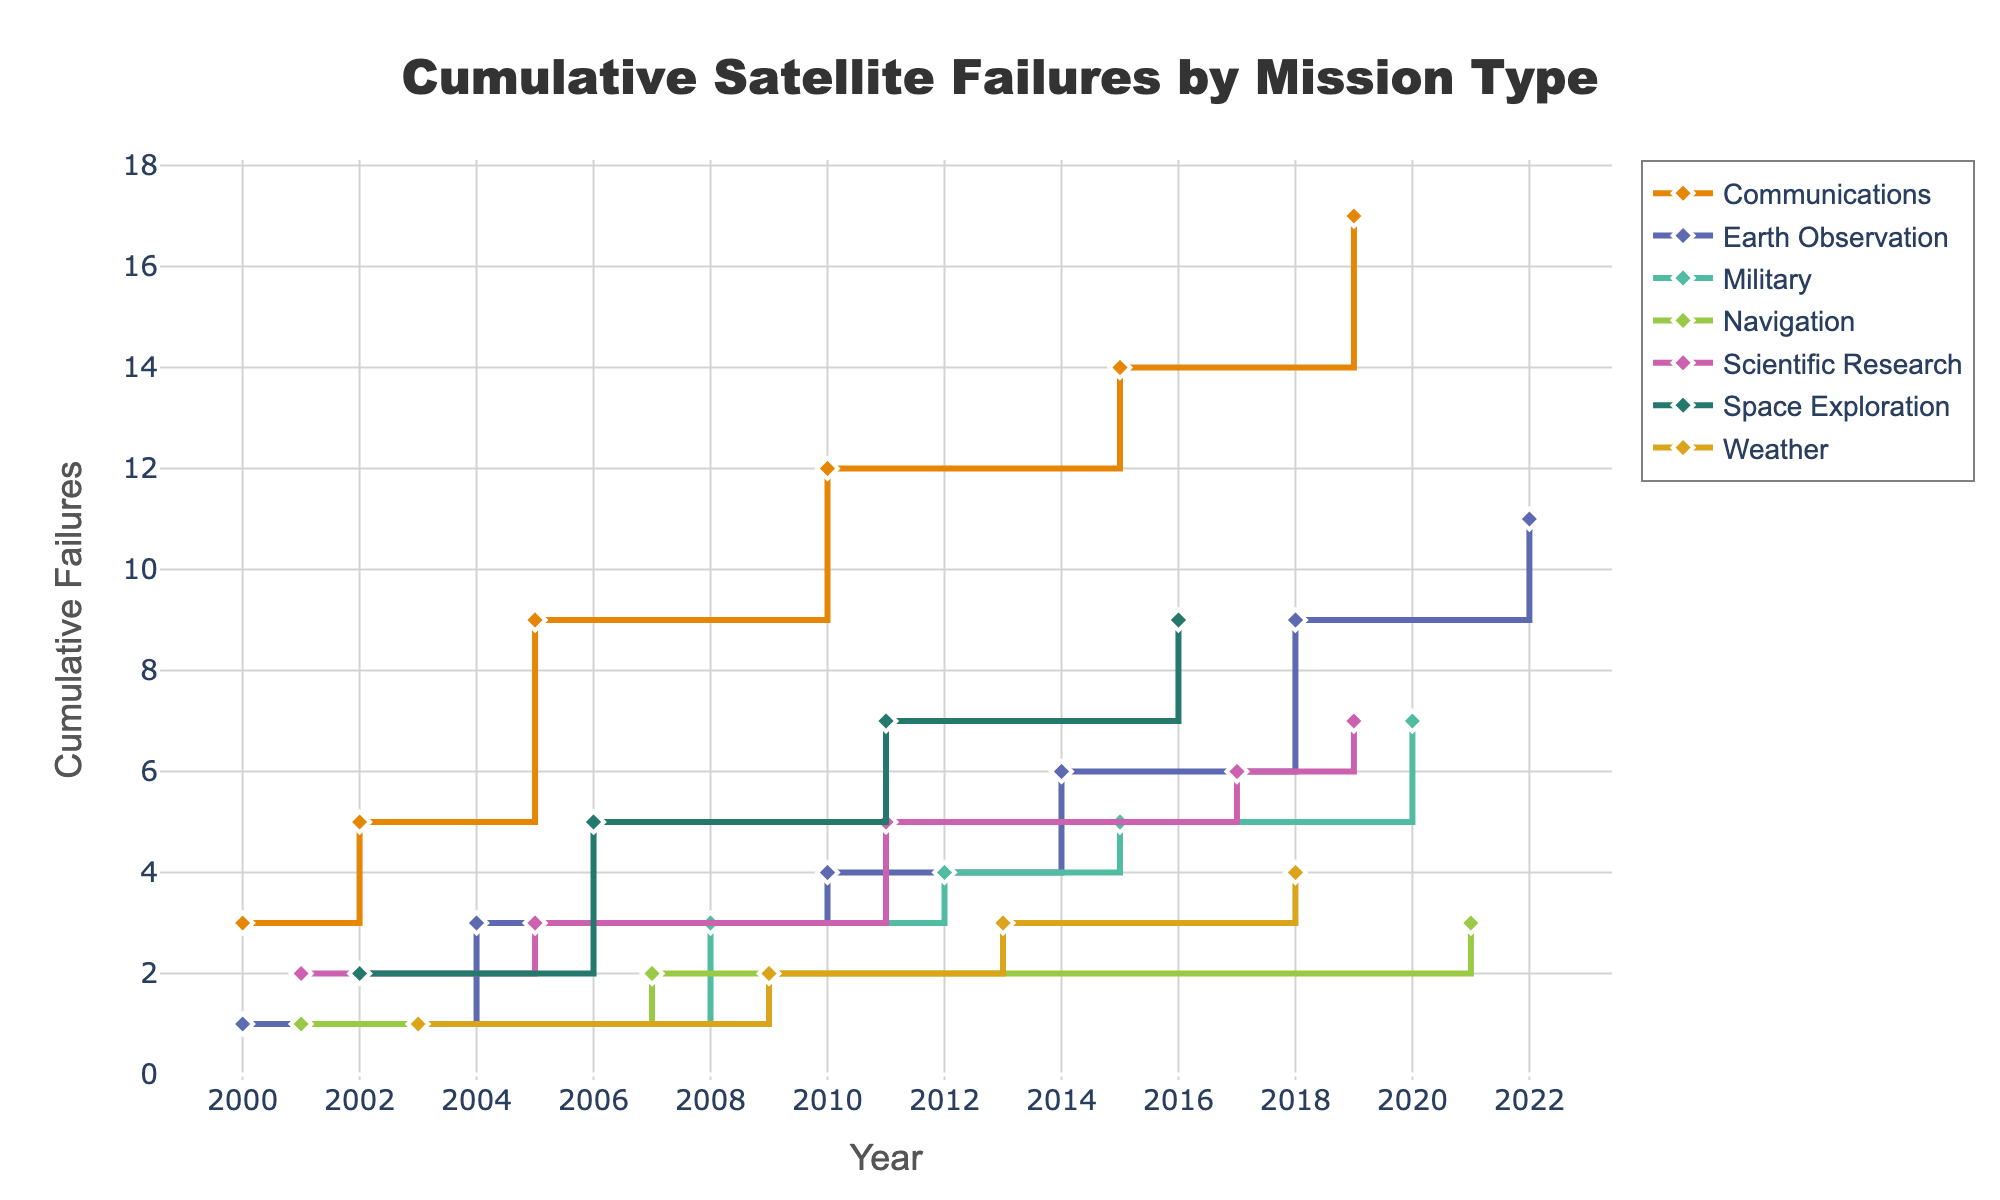What's the title of the plot? The title of the plot is displayed at the top center of the figure and reads "Cumulative Satellite Failures by Mission Type."
Answer: Cumulative Satellite Failures by Mission Type What is represented on the x-axis? The x-axis represents "Year," which indicates the years ranging from 2000 to 2022.
Answer: Year How many cumulative failures are present for the "Communications" mission type by the year 2019? Identify the trend line for the "Communications" mission type and find the cumulative failures at the point marked for the year 2019. The cumulative failures for "Communications" in 2019 are 15.
Answer: 15 Which mission type has the highest cumulative failures by 2022? Observe the final cumulative values for each line representing different mission types in the year 2022. The "Communications" mission type has the highest cumulative failures by 2022.
Answer: Communications How many mission types are there in total? Count the distinct lines (each with different colors and possibly different markers) representing various mission types in the plot. There are 8 distinct mission types.
Answer: 8 Comparing "Military" and "Weather," which mission type had more cumulative failures by 2015? Identify the trend lines for "Military" and "Weather" and compare their respective cumulative failures at the year 2015. "Military" had more cumulative failures by 2015 (with 1 for "Weather" and 4 for "Military").
Answer: Military What is the cumulative difference in failures between "Scientific Research" and "Navigation" by 2021? Track the cumulative trend lines for "Scientific Research" and "Navigation" and calculate the difference in their cumulative failures by 2021 (10 for "Scientific Research" - 3 for "Navigation" = 7).
Answer: 7 How did the "Space Exploration" mission type's cumulative failures change from 2010 to 2016? Examine the "Space Exploration" trend line and note the difference in cumulative failures from 2010 to 2016 (5 in 2010 to 9 in 2016). The changes indicate an increase of 4 cumulative failures over these years.
Answer: Increased by 4 Which mission type had the least cumulative failures by 2022? Observe the cumulative failures at the endpoints of all the trend lines in the year 2022. "Navigation" with 3 cumulative failures has the least by 2022.
Answer: Navigation 